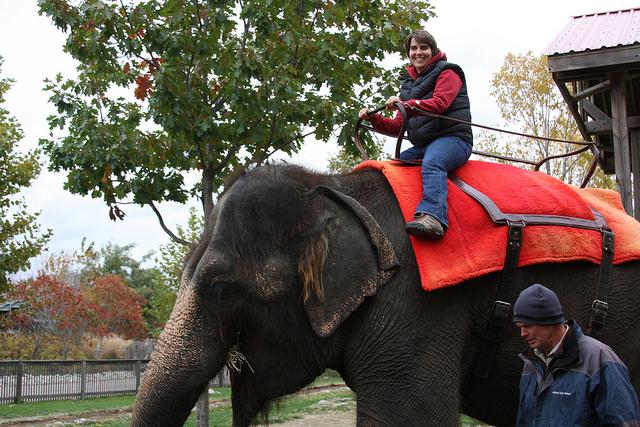What Animal is the woman riding in this scene?
Answer briefly. Elephant. What is the person riding on?
Keep it brief. Elephant. Is the girl on top of the elephant safe?
Be succinct. Yes. Who is riding the elephant?
Keep it brief. Woman. Why does the elephant have a blanket?
Quick response, please. For riding. Is the lady happy?
Quick response, please. Yes. 